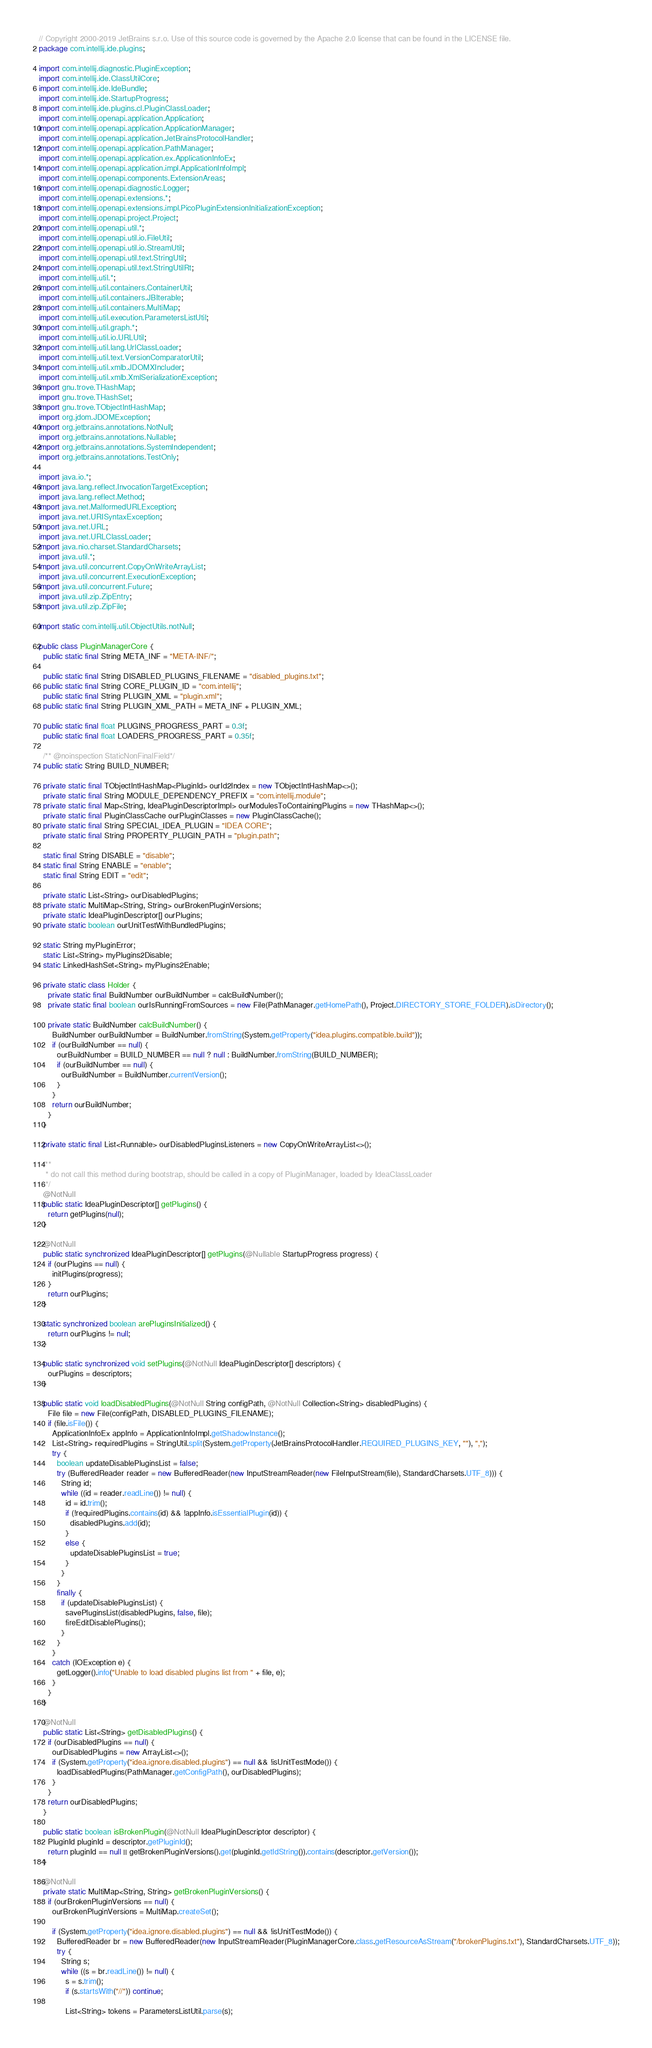<code> <loc_0><loc_0><loc_500><loc_500><_Java_>// Copyright 2000-2019 JetBrains s.r.o. Use of this source code is governed by the Apache 2.0 license that can be found in the LICENSE file.
package com.intellij.ide.plugins;

import com.intellij.diagnostic.PluginException;
import com.intellij.ide.ClassUtilCore;
import com.intellij.ide.IdeBundle;
import com.intellij.ide.StartupProgress;
import com.intellij.ide.plugins.cl.PluginClassLoader;
import com.intellij.openapi.application.Application;
import com.intellij.openapi.application.ApplicationManager;
import com.intellij.openapi.application.JetBrainsProtocolHandler;
import com.intellij.openapi.application.PathManager;
import com.intellij.openapi.application.ex.ApplicationInfoEx;
import com.intellij.openapi.application.impl.ApplicationInfoImpl;
import com.intellij.openapi.components.ExtensionAreas;
import com.intellij.openapi.diagnostic.Logger;
import com.intellij.openapi.extensions.*;
import com.intellij.openapi.extensions.impl.PicoPluginExtensionInitializationException;
import com.intellij.openapi.project.Project;
import com.intellij.openapi.util.*;
import com.intellij.openapi.util.io.FileUtil;
import com.intellij.openapi.util.io.StreamUtil;
import com.intellij.openapi.util.text.StringUtil;
import com.intellij.openapi.util.text.StringUtilRt;
import com.intellij.util.*;
import com.intellij.util.containers.ContainerUtil;
import com.intellij.util.containers.JBIterable;
import com.intellij.util.containers.MultiMap;
import com.intellij.util.execution.ParametersListUtil;
import com.intellij.util.graph.*;
import com.intellij.util.io.URLUtil;
import com.intellij.util.lang.UrlClassLoader;
import com.intellij.util.text.VersionComparatorUtil;
import com.intellij.util.xmlb.JDOMXIncluder;
import com.intellij.util.xmlb.XmlSerializationException;
import gnu.trove.THashMap;
import gnu.trove.THashSet;
import gnu.trove.TObjectIntHashMap;
import org.jdom.JDOMException;
import org.jetbrains.annotations.NotNull;
import org.jetbrains.annotations.Nullable;
import org.jetbrains.annotations.SystemIndependent;
import org.jetbrains.annotations.TestOnly;

import java.io.*;
import java.lang.reflect.InvocationTargetException;
import java.lang.reflect.Method;
import java.net.MalformedURLException;
import java.net.URISyntaxException;
import java.net.URL;
import java.net.URLClassLoader;
import java.nio.charset.StandardCharsets;
import java.util.*;
import java.util.concurrent.CopyOnWriteArrayList;
import java.util.concurrent.ExecutionException;
import java.util.concurrent.Future;
import java.util.zip.ZipEntry;
import java.util.zip.ZipFile;

import static com.intellij.util.ObjectUtils.notNull;

public class PluginManagerCore {
  public static final String META_INF = "META-INF/";

  public static final String DISABLED_PLUGINS_FILENAME = "disabled_plugins.txt";
  public static final String CORE_PLUGIN_ID = "com.intellij";
  public static final String PLUGIN_XML = "plugin.xml";
  public static final String PLUGIN_XML_PATH = META_INF + PLUGIN_XML;

  public static final float PLUGINS_PROGRESS_PART = 0.3f;
  public static final float LOADERS_PROGRESS_PART = 0.35f;

  /** @noinspection StaticNonFinalField*/
  public static String BUILD_NUMBER;

  private static final TObjectIntHashMap<PluginId> ourId2Index = new TObjectIntHashMap<>();
  private static final String MODULE_DEPENDENCY_PREFIX = "com.intellij.module";
  private static final Map<String, IdeaPluginDescriptorImpl> ourModulesToContainingPlugins = new THashMap<>();
  private static final PluginClassCache ourPluginClasses = new PluginClassCache();
  private static final String SPECIAL_IDEA_PLUGIN = "IDEA CORE";
  private static final String PROPERTY_PLUGIN_PATH = "plugin.path";

  static final String DISABLE = "disable";
  static final String ENABLE = "enable";
  static final String EDIT = "edit";

  private static List<String> ourDisabledPlugins;
  private static MultiMap<String, String> ourBrokenPluginVersions;
  private static IdeaPluginDescriptor[] ourPlugins;
  private static boolean ourUnitTestWithBundledPlugins;

  static String myPluginError;
  static List<String> myPlugins2Disable;
  static LinkedHashSet<String> myPlugins2Enable;

  private static class Holder {
    private static final BuildNumber ourBuildNumber = calcBuildNumber();
    private static final boolean ourIsRunningFromSources = new File(PathManager.getHomePath(), Project.DIRECTORY_STORE_FOLDER).isDirectory();

    private static BuildNumber calcBuildNumber() {
      BuildNumber ourBuildNumber = BuildNumber.fromString(System.getProperty("idea.plugins.compatible.build"));
      if (ourBuildNumber == null) {
        ourBuildNumber = BUILD_NUMBER == null ? null : BuildNumber.fromString(BUILD_NUMBER);
        if (ourBuildNumber == null) {
          ourBuildNumber = BuildNumber.currentVersion();
        }
      }
      return ourBuildNumber;
    }
  }

  private static final List<Runnable> ourDisabledPluginsListeners = new CopyOnWriteArrayList<>();

  /**
   * do not call this method during bootstrap, should be called in a copy of PluginManager, loaded by IdeaClassLoader
   */
  @NotNull
  public static IdeaPluginDescriptor[] getPlugins() {
    return getPlugins(null);
  }

  @NotNull
  public static synchronized IdeaPluginDescriptor[] getPlugins(@Nullable StartupProgress progress) {
    if (ourPlugins == null) {
      initPlugins(progress);
    }
    return ourPlugins;
  }

  static synchronized boolean arePluginsInitialized() {
    return ourPlugins != null;
  }

  public static synchronized void setPlugins(@NotNull IdeaPluginDescriptor[] descriptors) {
    ourPlugins = descriptors;
  }

  public static void loadDisabledPlugins(@NotNull String configPath, @NotNull Collection<String> disabledPlugins) {
    File file = new File(configPath, DISABLED_PLUGINS_FILENAME);
    if (file.isFile()) {
      ApplicationInfoEx appInfo = ApplicationInfoImpl.getShadowInstance();
      List<String> requiredPlugins = StringUtil.split(System.getProperty(JetBrainsProtocolHandler.REQUIRED_PLUGINS_KEY, ""), ",");
      try {
        boolean updateDisablePluginsList = false;
        try (BufferedReader reader = new BufferedReader(new InputStreamReader(new FileInputStream(file), StandardCharsets.UTF_8))) {
          String id;
          while ((id = reader.readLine()) != null) {
            id = id.trim();
            if (!requiredPlugins.contains(id) && !appInfo.isEssentialPlugin(id)) {
              disabledPlugins.add(id);
            }
            else {
              updateDisablePluginsList = true;
            }
          }
        }
        finally {
          if (updateDisablePluginsList) {
            savePluginsList(disabledPlugins, false, file);
            fireEditDisablePlugins();
          }
        }
      }
      catch (IOException e) {
        getLogger().info("Unable to load disabled plugins list from " + file, e);
      }
    }
  }

  @NotNull
  public static List<String> getDisabledPlugins() {
    if (ourDisabledPlugins == null) {
      ourDisabledPlugins = new ArrayList<>();
      if (System.getProperty("idea.ignore.disabled.plugins") == null && !isUnitTestMode()) {
        loadDisabledPlugins(PathManager.getConfigPath(), ourDisabledPlugins);
      }
    }
    return ourDisabledPlugins;
  }

  public static boolean isBrokenPlugin(@NotNull IdeaPluginDescriptor descriptor) {
    PluginId pluginId = descriptor.getPluginId();
    return pluginId == null || getBrokenPluginVersions().get(pluginId.getIdString()).contains(descriptor.getVersion());
  }

  @NotNull
  private static MultiMap<String, String> getBrokenPluginVersions() {
    if (ourBrokenPluginVersions == null) {
      ourBrokenPluginVersions = MultiMap.createSet();

      if (System.getProperty("idea.ignore.disabled.plugins") == null && !isUnitTestMode()) {
        BufferedReader br = new BufferedReader(new InputStreamReader(PluginManagerCore.class.getResourceAsStream("/brokenPlugins.txt"), StandardCharsets.UTF_8));
        try {
          String s;
          while ((s = br.readLine()) != null) {
            s = s.trim();
            if (s.startsWith("//")) continue;

            List<String> tokens = ParametersListUtil.parse(s);</code> 